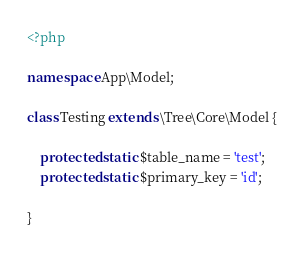Convert code to text. <code><loc_0><loc_0><loc_500><loc_500><_PHP_><?php

namespace App\Model;
	
class Testing extends \Tree\Core\Model {
	
	protected static $table_name = 'test';
	protected static $primary_key = 'id';
	
}</code> 